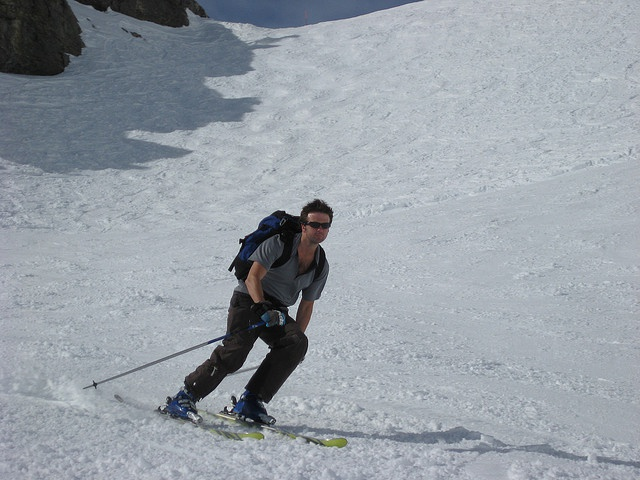Describe the objects in this image and their specific colors. I can see people in black, gray, and maroon tones, skis in black, darkgray, gray, and olive tones, and backpack in black, navy, gray, and darkgray tones in this image. 